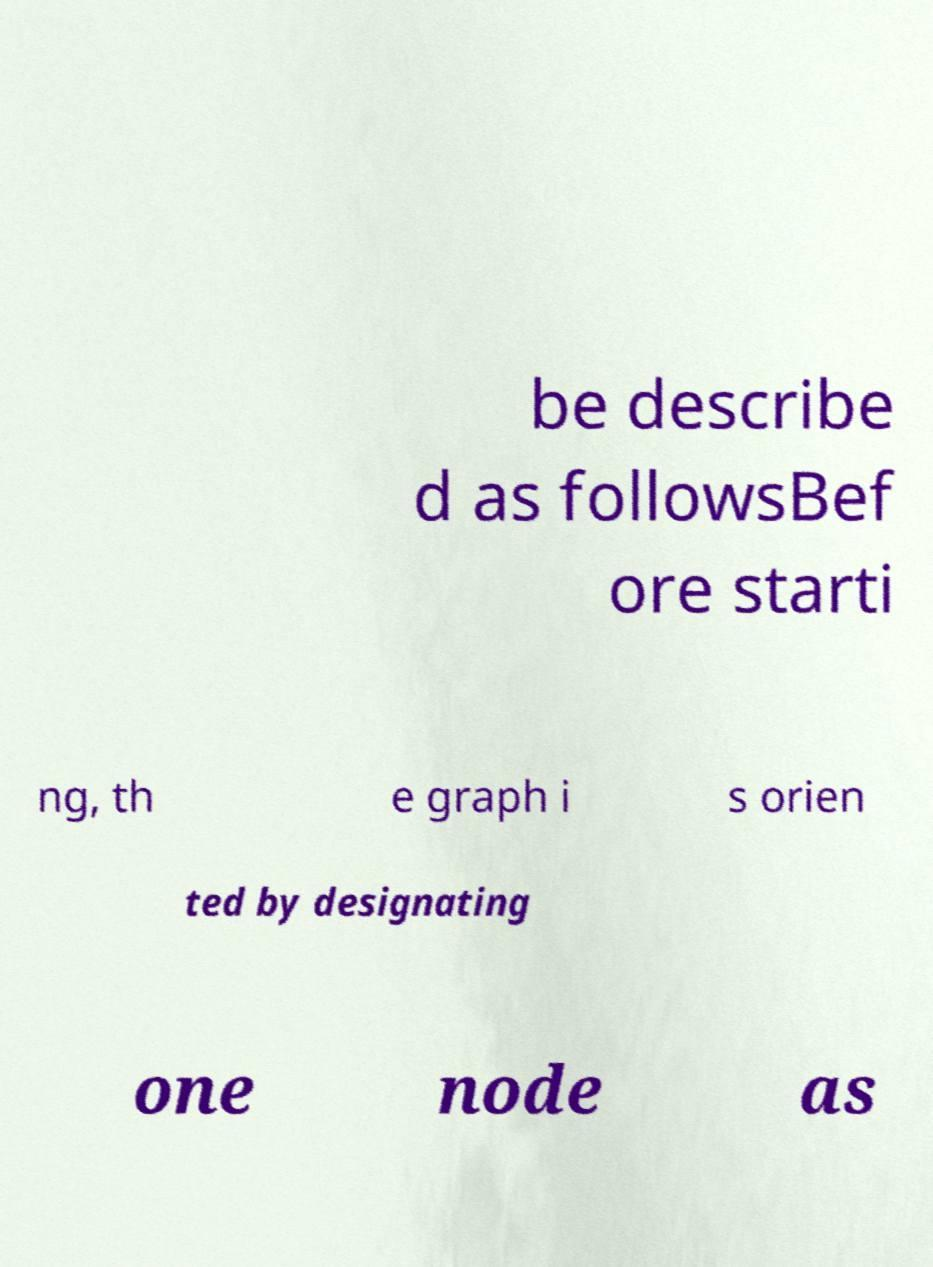Please read and relay the text visible in this image. What does it say? be describe d as followsBef ore starti ng, th e graph i s orien ted by designating one node as 